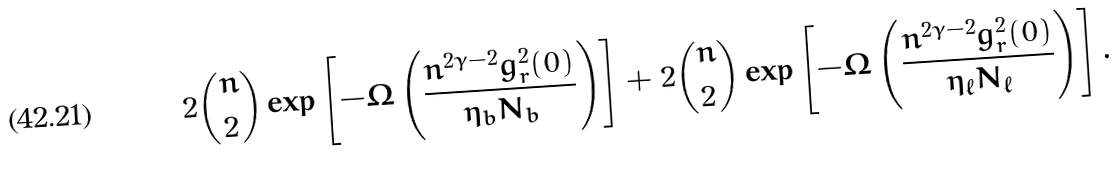<formula> <loc_0><loc_0><loc_500><loc_500>2 \binom { n } { 2 } \exp \left [ - \Omega \left ( \frac { n ^ { 2 \gamma - 2 } g _ { r } ^ { 2 } ( 0 ) } { \eta _ { b } N _ { b } } \right ) \right ] + 2 \binom { n } { 2 } \exp \left [ - \Omega \left ( \frac { n ^ { 2 \gamma - 2 } g _ { r } ^ { 2 } ( 0 ) } { \eta _ { \ell } N _ { \ell } } \right ) \right ] .</formula> 